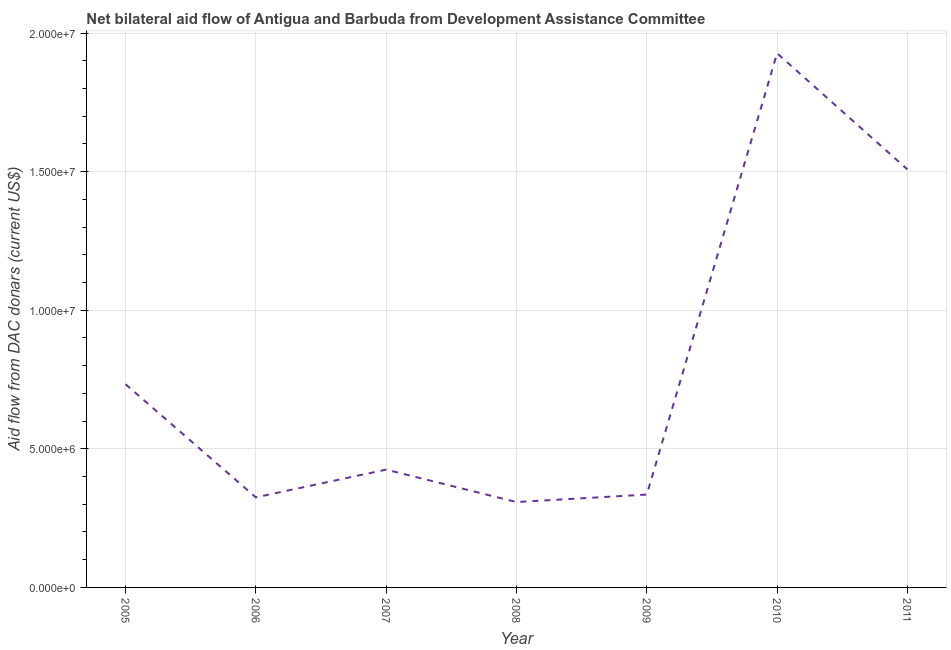What is the net bilateral aid flows from dac donors in 2005?
Offer a very short reply. 7.33e+06. Across all years, what is the maximum net bilateral aid flows from dac donors?
Give a very brief answer. 1.93e+07. Across all years, what is the minimum net bilateral aid flows from dac donors?
Your answer should be very brief. 3.08e+06. In which year was the net bilateral aid flows from dac donors maximum?
Your answer should be compact. 2010. In which year was the net bilateral aid flows from dac donors minimum?
Your answer should be compact. 2008. What is the sum of the net bilateral aid flows from dac donors?
Ensure brevity in your answer.  5.56e+07. What is the difference between the net bilateral aid flows from dac donors in 2005 and 2007?
Make the answer very short. 3.08e+06. What is the average net bilateral aid flows from dac donors per year?
Keep it short and to the point. 7.94e+06. What is the median net bilateral aid flows from dac donors?
Make the answer very short. 4.25e+06. In how many years, is the net bilateral aid flows from dac donors greater than 19000000 US$?
Ensure brevity in your answer.  1. What is the ratio of the net bilateral aid flows from dac donors in 2008 to that in 2011?
Your answer should be very brief. 0.2. Is the net bilateral aid flows from dac donors in 2007 less than that in 2008?
Ensure brevity in your answer.  No. What is the difference between the highest and the second highest net bilateral aid flows from dac donors?
Give a very brief answer. 4.19e+06. Is the sum of the net bilateral aid flows from dac donors in 2009 and 2011 greater than the maximum net bilateral aid flows from dac donors across all years?
Keep it short and to the point. No. What is the difference between the highest and the lowest net bilateral aid flows from dac donors?
Your response must be concise. 1.62e+07. In how many years, is the net bilateral aid flows from dac donors greater than the average net bilateral aid flows from dac donors taken over all years?
Offer a very short reply. 2. How many lines are there?
Your response must be concise. 1. How many years are there in the graph?
Your answer should be very brief. 7. Are the values on the major ticks of Y-axis written in scientific E-notation?
Keep it short and to the point. Yes. Does the graph contain any zero values?
Give a very brief answer. No. Does the graph contain grids?
Offer a terse response. Yes. What is the title of the graph?
Make the answer very short. Net bilateral aid flow of Antigua and Barbuda from Development Assistance Committee. What is the label or title of the X-axis?
Provide a short and direct response. Year. What is the label or title of the Y-axis?
Give a very brief answer. Aid flow from DAC donars (current US$). What is the Aid flow from DAC donars (current US$) of 2005?
Your response must be concise. 7.33e+06. What is the Aid flow from DAC donars (current US$) of 2006?
Your answer should be compact. 3.25e+06. What is the Aid flow from DAC donars (current US$) of 2007?
Your response must be concise. 4.25e+06. What is the Aid flow from DAC donars (current US$) of 2008?
Ensure brevity in your answer.  3.08e+06. What is the Aid flow from DAC donars (current US$) of 2009?
Provide a succinct answer. 3.35e+06. What is the Aid flow from DAC donars (current US$) in 2010?
Keep it short and to the point. 1.93e+07. What is the Aid flow from DAC donars (current US$) of 2011?
Offer a very short reply. 1.51e+07. What is the difference between the Aid flow from DAC donars (current US$) in 2005 and 2006?
Keep it short and to the point. 4.08e+06. What is the difference between the Aid flow from DAC donars (current US$) in 2005 and 2007?
Offer a very short reply. 3.08e+06. What is the difference between the Aid flow from DAC donars (current US$) in 2005 and 2008?
Keep it short and to the point. 4.25e+06. What is the difference between the Aid flow from DAC donars (current US$) in 2005 and 2009?
Provide a short and direct response. 3.98e+06. What is the difference between the Aid flow from DAC donars (current US$) in 2005 and 2010?
Your answer should be very brief. -1.19e+07. What is the difference between the Aid flow from DAC donars (current US$) in 2005 and 2011?
Your answer should be very brief. -7.75e+06. What is the difference between the Aid flow from DAC donars (current US$) in 2006 and 2007?
Make the answer very short. -1.00e+06. What is the difference between the Aid flow from DAC donars (current US$) in 2006 and 2008?
Provide a succinct answer. 1.70e+05. What is the difference between the Aid flow from DAC donars (current US$) in 2006 and 2009?
Keep it short and to the point. -1.00e+05. What is the difference between the Aid flow from DAC donars (current US$) in 2006 and 2010?
Keep it short and to the point. -1.60e+07. What is the difference between the Aid flow from DAC donars (current US$) in 2006 and 2011?
Offer a terse response. -1.18e+07. What is the difference between the Aid flow from DAC donars (current US$) in 2007 and 2008?
Make the answer very short. 1.17e+06. What is the difference between the Aid flow from DAC donars (current US$) in 2007 and 2010?
Your response must be concise. -1.50e+07. What is the difference between the Aid flow from DAC donars (current US$) in 2007 and 2011?
Your response must be concise. -1.08e+07. What is the difference between the Aid flow from DAC donars (current US$) in 2008 and 2009?
Your answer should be compact. -2.70e+05. What is the difference between the Aid flow from DAC donars (current US$) in 2008 and 2010?
Offer a very short reply. -1.62e+07. What is the difference between the Aid flow from DAC donars (current US$) in 2008 and 2011?
Your answer should be very brief. -1.20e+07. What is the difference between the Aid flow from DAC donars (current US$) in 2009 and 2010?
Keep it short and to the point. -1.59e+07. What is the difference between the Aid flow from DAC donars (current US$) in 2009 and 2011?
Give a very brief answer. -1.17e+07. What is the difference between the Aid flow from DAC donars (current US$) in 2010 and 2011?
Offer a very short reply. 4.19e+06. What is the ratio of the Aid flow from DAC donars (current US$) in 2005 to that in 2006?
Offer a terse response. 2.25. What is the ratio of the Aid flow from DAC donars (current US$) in 2005 to that in 2007?
Provide a short and direct response. 1.73. What is the ratio of the Aid flow from DAC donars (current US$) in 2005 to that in 2008?
Give a very brief answer. 2.38. What is the ratio of the Aid flow from DAC donars (current US$) in 2005 to that in 2009?
Make the answer very short. 2.19. What is the ratio of the Aid flow from DAC donars (current US$) in 2005 to that in 2010?
Give a very brief answer. 0.38. What is the ratio of the Aid flow from DAC donars (current US$) in 2005 to that in 2011?
Your answer should be compact. 0.49. What is the ratio of the Aid flow from DAC donars (current US$) in 2006 to that in 2007?
Keep it short and to the point. 0.77. What is the ratio of the Aid flow from DAC donars (current US$) in 2006 to that in 2008?
Your answer should be compact. 1.05. What is the ratio of the Aid flow from DAC donars (current US$) in 2006 to that in 2010?
Your answer should be compact. 0.17. What is the ratio of the Aid flow from DAC donars (current US$) in 2006 to that in 2011?
Your answer should be very brief. 0.22. What is the ratio of the Aid flow from DAC donars (current US$) in 2007 to that in 2008?
Provide a short and direct response. 1.38. What is the ratio of the Aid flow from DAC donars (current US$) in 2007 to that in 2009?
Give a very brief answer. 1.27. What is the ratio of the Aid flow from DAC donars (current US$) in 2007 to that in 2010?
Provide a succinct answer. 0.22. What is the ratio of the Aid flow from DAC donars (current US$) in 2007 to that in 2011?
Offer a terse response. 0.28. What is the ratio of the Aid flow from DAC donars (current US$) in 2008 to that in 2009?
Offer a very short reply. 0.92. What is the ratio of the Aid flow from DAC donars (current US$) in 2008 to that in 2010?
Keep it short and to the point. 0.16. What is the ratio of the Aid flow from DAC donars (current US$) in 2008 to that in 2011?
Your answer should be compact. 0.2. What is the ratio of the Aid flow from DAC donars (current US$) in 2009 to that in 2010?
Offer a terse response. 0.17. What is the ratio of the Aid flow from DAC donars (current US$) in 2009 to that in 2011?
Ensure brevity in your answer.  0.22. What is the ratio of the Aid flow from DAC donars (current US$) in 2010 to that in 2011?
Provide a short and direct response. 1.28. 